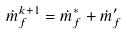Convert formula to latex. <formula><loc_0><loc_0><loc_500><loc_500>\dot { m } _ { f } ^ { k + 1 } = \dot { m } _ { f } ^ { * } + \dot { m } _ { f } ^ { \prime }</formula> 